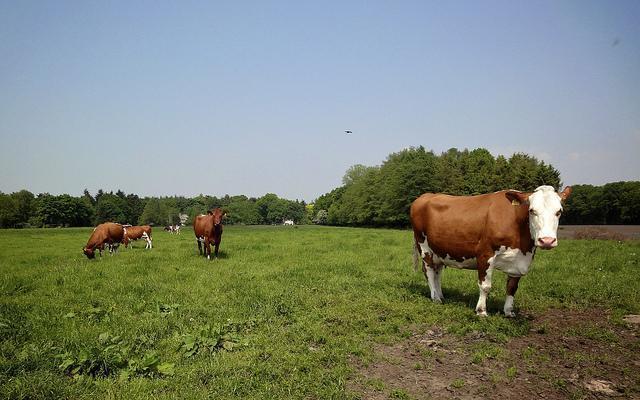How many cows are present?
Give a very brief answer. 5. 